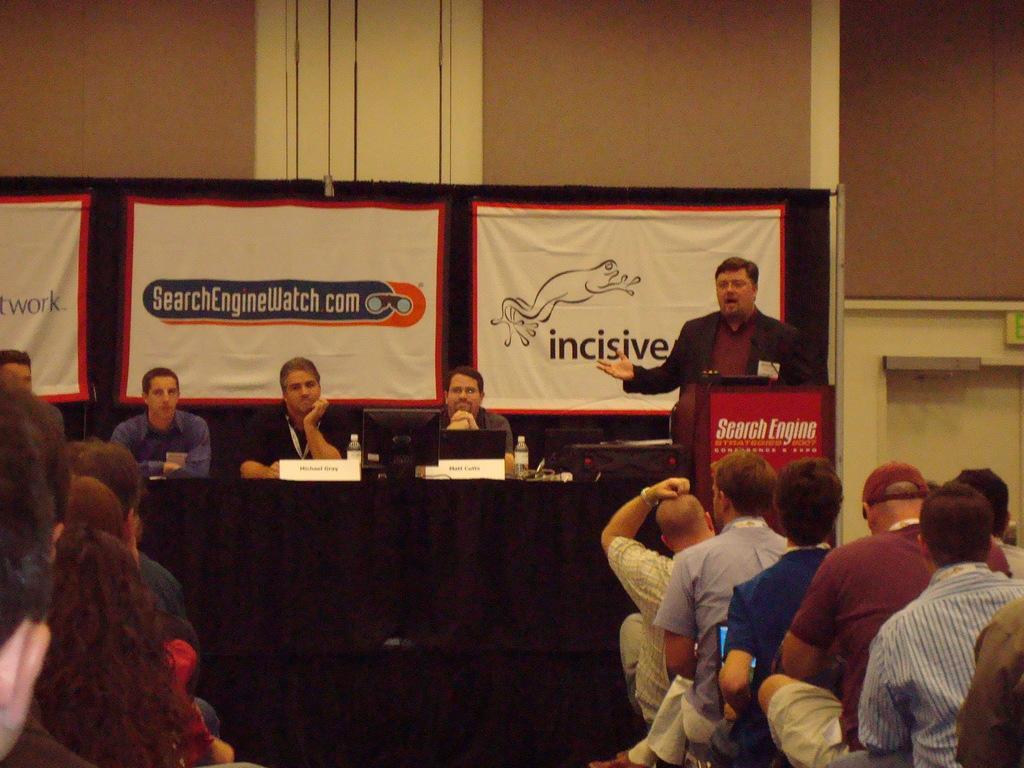Please provide a concise description of this image. This picture is taken inside the room. In this image, on the right side, we can see a group of people sitting on the chair. On the left side, we can also see a group of people sitting on the chair. In the middle of the image, we can also see a table, on the table, we can see a black color cloth, board and a laptop. On the right side, we can also see a man wearing a black color shirt is standing in front of the podium. On the podium, we can see a paper and a microphone. In the background, we can see some hoardings with some pictures and text on it. In the background, we can see a wall. 